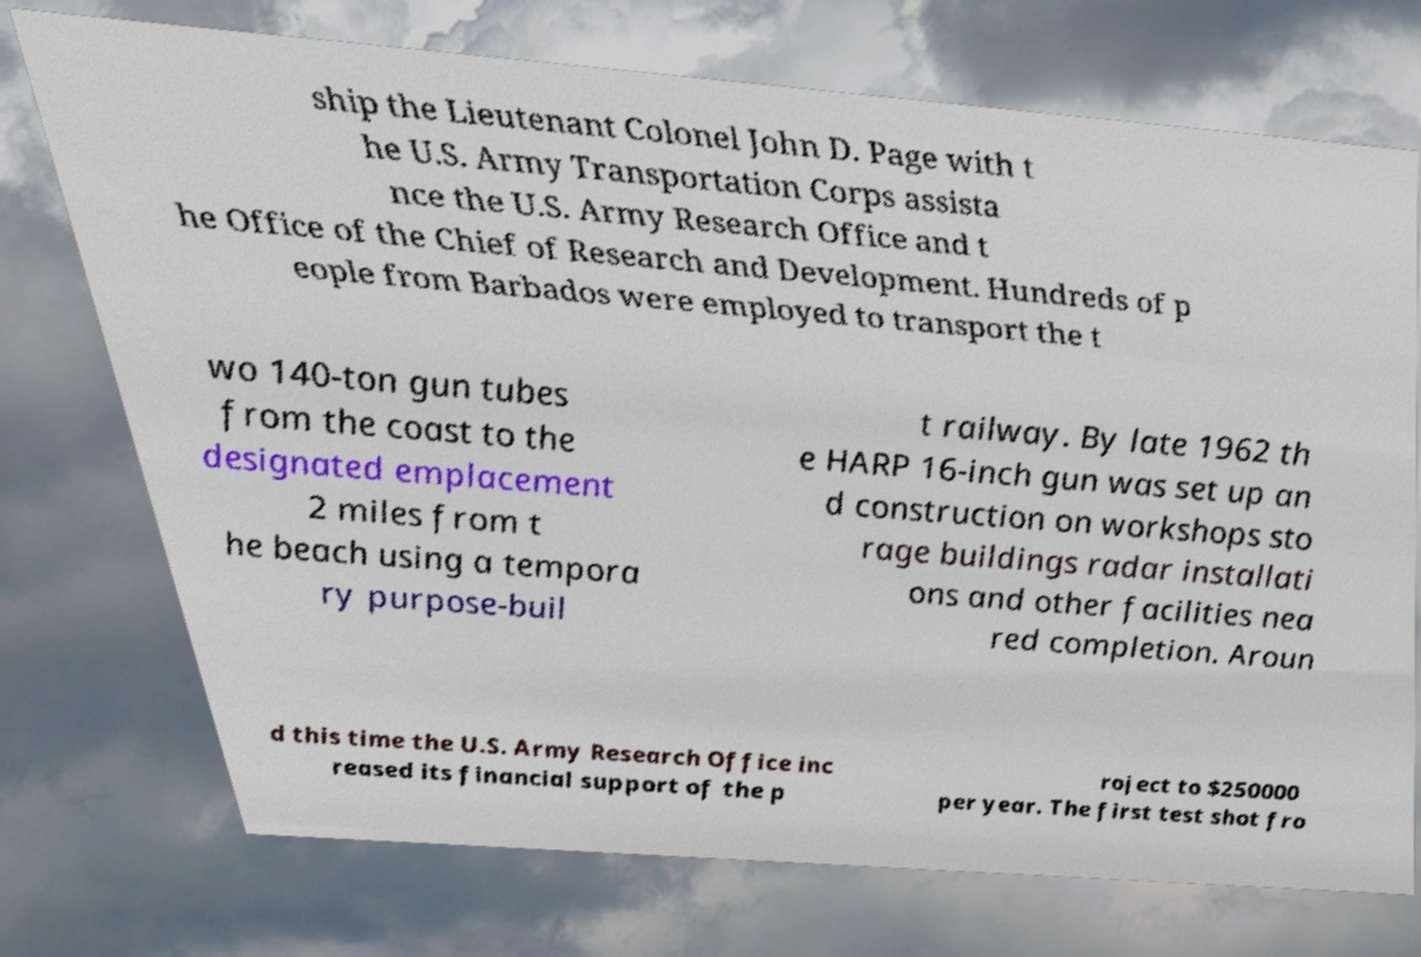Could you assist in decoding the text presented in this image and type it out clearly? ship the Lieutenant Colonel John D. Page with t he U.S. Army Transportation Corps assista nce the U.S. Army Research Office and t he Office of the Chief of Research and Development. Hundreds of p eople from Barbados were employed to transport the t wo 140-ton gun tubes from the coast to the designated emplacement 2 miles from t he beach using a tempora ry purpose-buil t railway. By late 1962 th e HARP 16-inch gun was set up an d construction on workshops sto rage buildings radar installati ons and other facilities nea red completion. Aroun d this time the U.S. Army Research Office inc reased its financial support of the p roject to $250000 per year. The first test shot fro 